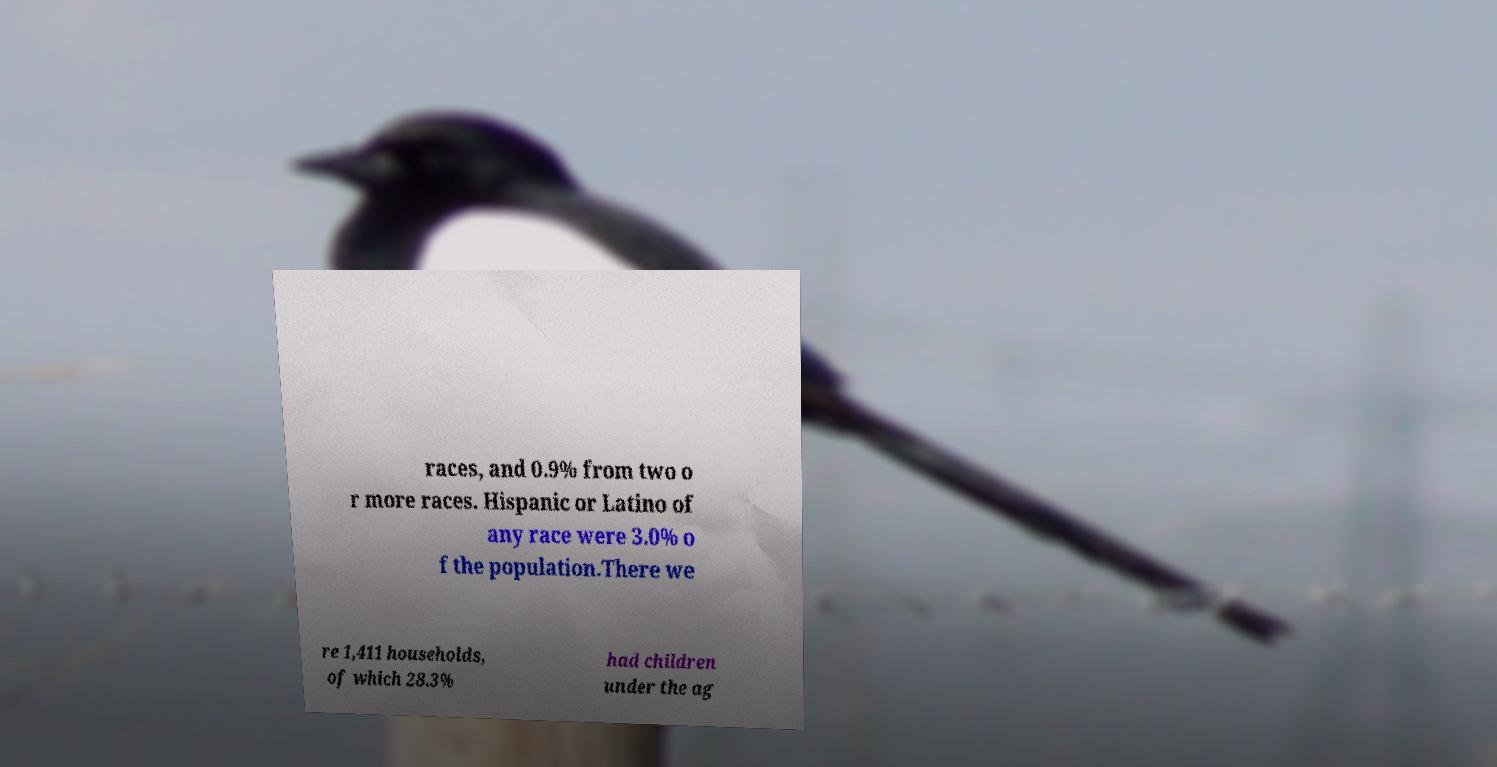I need the written content from this picture converted into text. Can you do that? races, and 0.9% from two o r more races. Hispanic or Latino of any race were 3.0% o f the population.There we re 1,411 households, of which 28.3% had children under the ag 